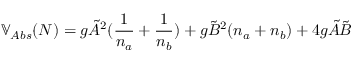Convert formula to latex. <formula><loc_0><loc_0><loc_500><loc_500>\mathbb { V } _ { A b s } ( N ) = g \tilde { A } ^ { 2 } ( \frac { 1 } { n _ { a } } + \frac { 1 } { n _ { b } } ) + g \tilde { B } ^ { 2 } ( n _ { a } + n _ { b } ) + 4 g \tilde { A } \tilde { B }</formula> 